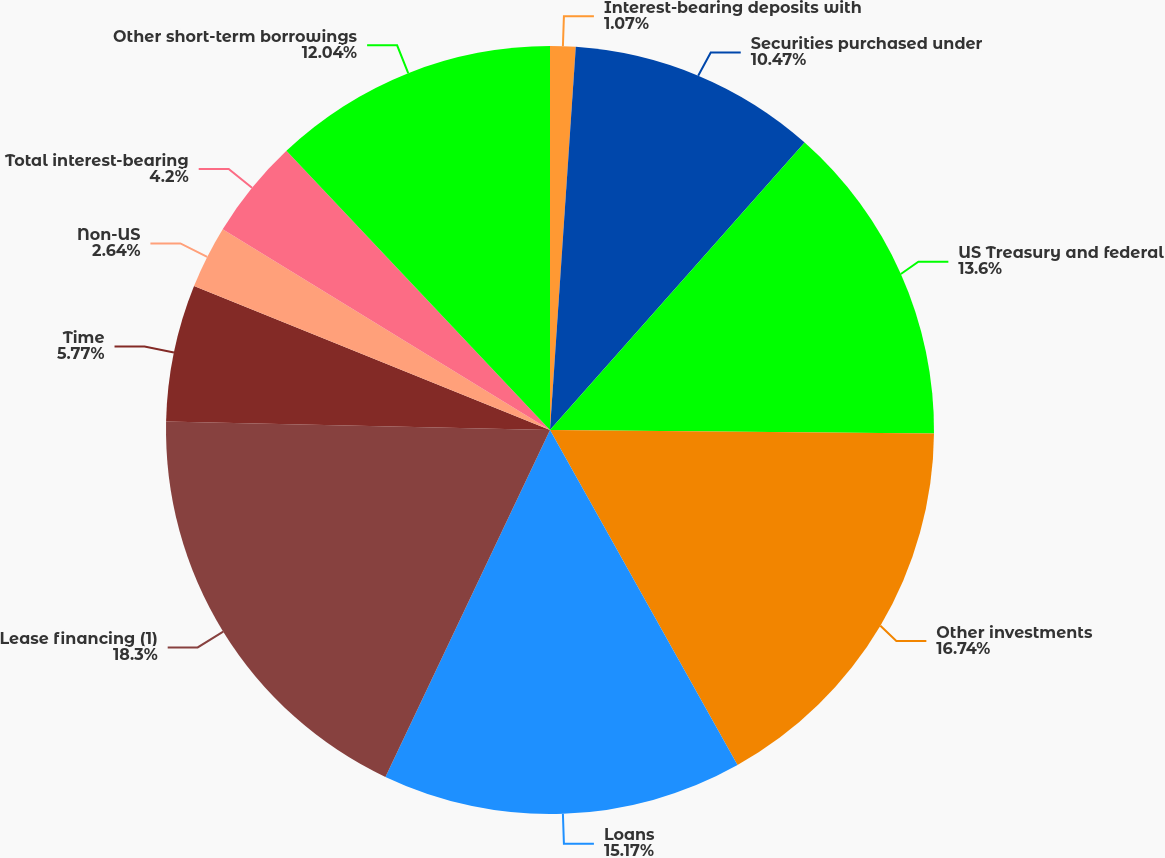<chart> <loc_0><loc_0><loc_500><loc_500><pie_chart><fcel>Interest-bearing deposits with<fcel>Securities purchased under<fcel>US Treasury and federal<fcel>Other investments<fcel>Loans<fcel>Lease financing (1)<fcel>Time<fcel>Non-US<fcel>Total interest-bearing<fcel>Other short-term borrowings<nl><fcel>1.07%<fcel>10.47%<fcel>13.6%<fcel>16.74%<fcel>15.17%<fcel>18.3%<fcel>5.77%<fcel>2.64%<fcel>4.2%<fcel>12.04%<nl></chart> 